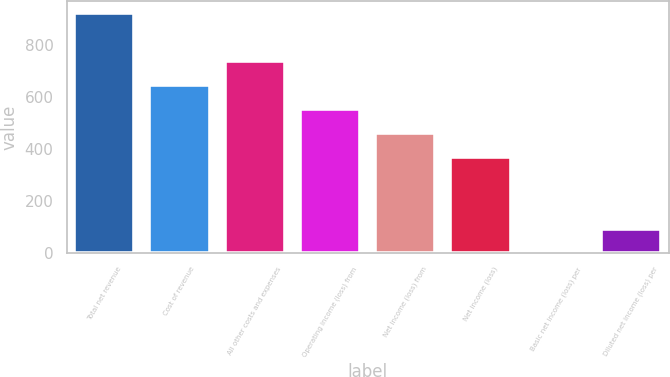Convert chart. <chart><loc_0><loc_0><loc_500><loc_500><bar_chart><fcel>Total net revenue<fcel>Cost of revenue<fcel>All other costs and expenses<fcel>Operating income (loss) from<fcel>Net income (loss) from<fcel>Net income (loss)<fcel>Basic net income (loss) per<fcel>Diluted net income (loss) per<nl><fcel>923<fcel>646.12<fcel>738.41<fcel>553.83<fcel>461.54<fcel>369.25<fcel>0.09<fcel>92.38<nl></chart> 